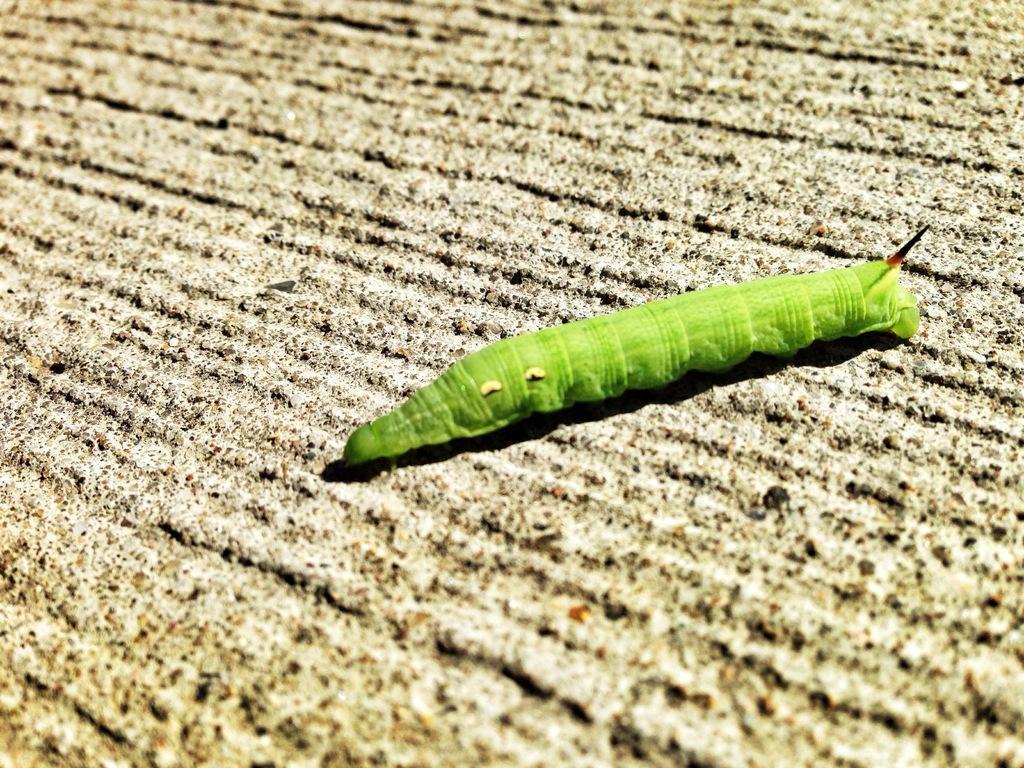Please provide a concise description of this image. In this image I can see a caterpillar which is in green color. At the bottom of the image I can see the land. 